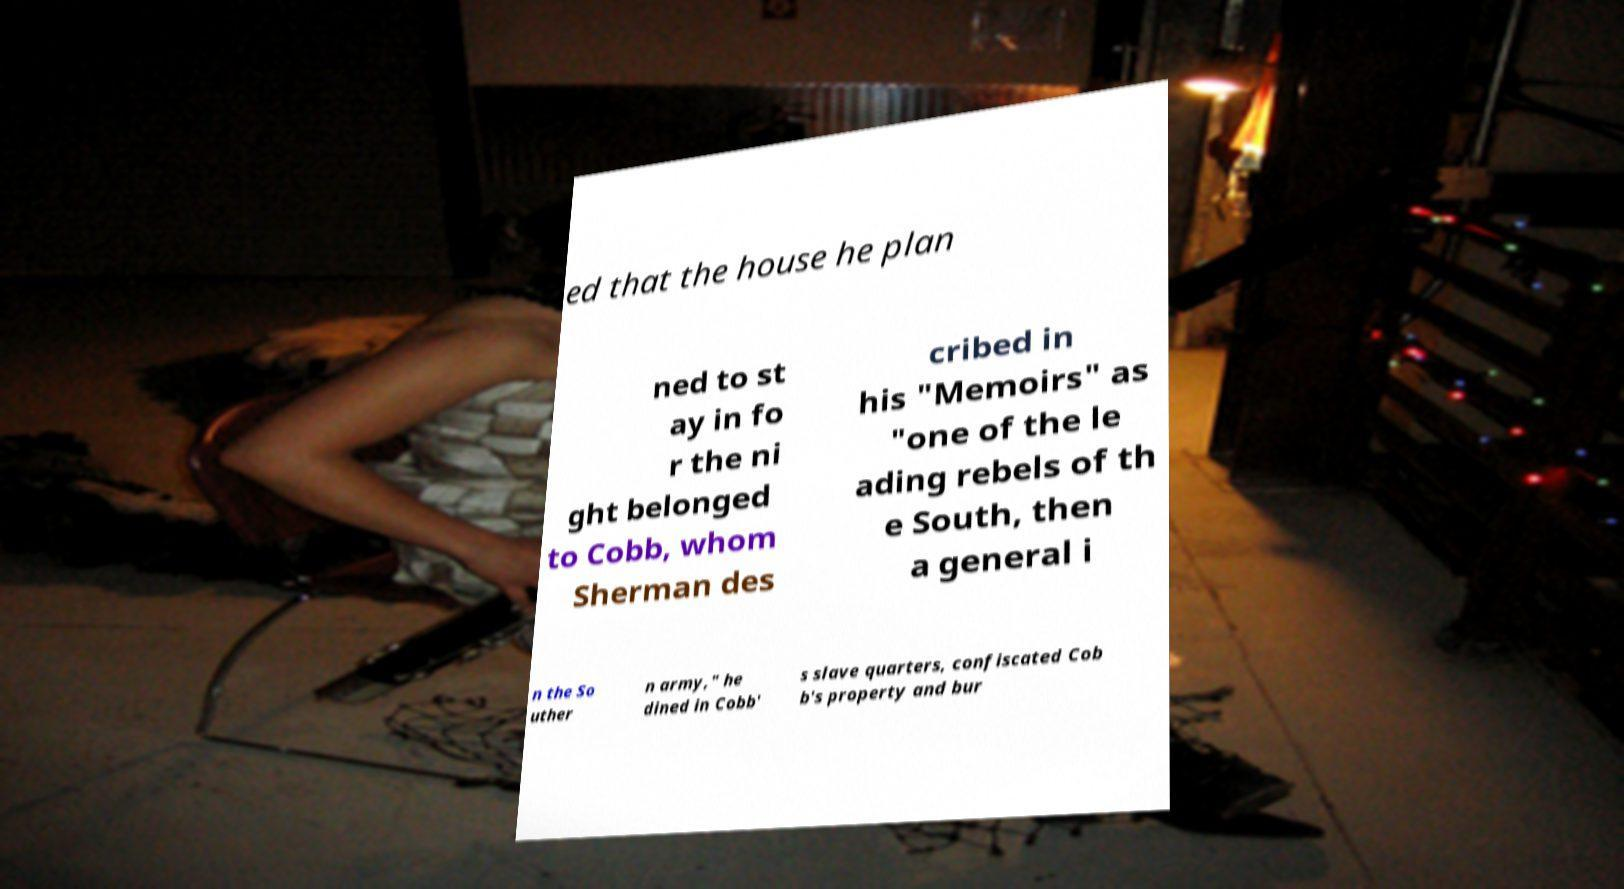Can you accurately transcribe the text from the provided image for me? ed that the house he plan ned to st ay in fo r the ni ght belonged to Cobb, whom Sherman des cribed in his "Memoirs" as "one of the le ading rebels of th e South, then a general i n the So uther n army," he dined in Cobb' s slave quarters, confiscated Cob b's property and bur 